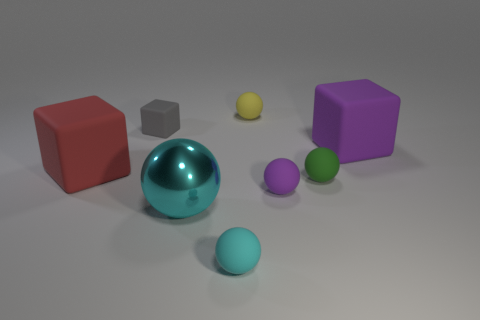Subtract all yellow balls. How many balls are left? 4 Subtract all large cyan metal spheres. How many spheres are left? 4 Subtract all red spheres. Subtract all purple cylinders. How many spheres are left? 5 Add 1 small things. How many objects exist? 9 Subtract all blocks. How many objects are left? 5 Add 3 metal things. How many metal things exist? 4 Subtract 0 purple cylinders. How many objects are left? 8 Subtract all tiny yellow rubber balls. Subtract all tiny yellow things. How many objects are left? 6 Add 7 cyan metal things. How many cyan metal things are left? 8 